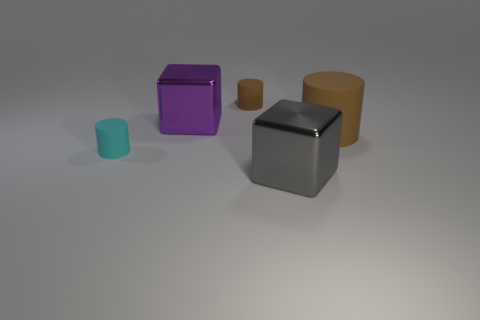What size is the gray thing that is made of the same material as the big purple thing?
Provide a short and direct response. Large. How many other purple objects have the same shape as the purple thing?
Your answer should be very brief. 0. Are there more rubber things that are in front of the big purple metallic object than purple things?
Your answer should be very brief. Yes. There is a thing that is in front of the big rubber cylinder and on the left side of the gray block; what is its shape?
Make the answer very short. Cylinder. Do the purple metal thing and the gray cube have the same size?
Ensure brevity in your answer.  Yes. How many cubes are in front of the large purple object?
Offer a terse response. 1. Are there an equal number of large rubber cylinders that are on the left side of the large purple object and brown rubber cylinders behind the tiny cyan object?
Keep it short and to the point. No. There is a tiny thing that is behind the large brown rubber thing; is it the same shape as the large brown rubber object?
Your response must be concise. Yes. Is the size of the cyan object the same as the block behind the big gray shiny object?
Provide a succinct answer. No. How many other things are there of the same color as the big cylinder?
Offer a terse response. 1. 